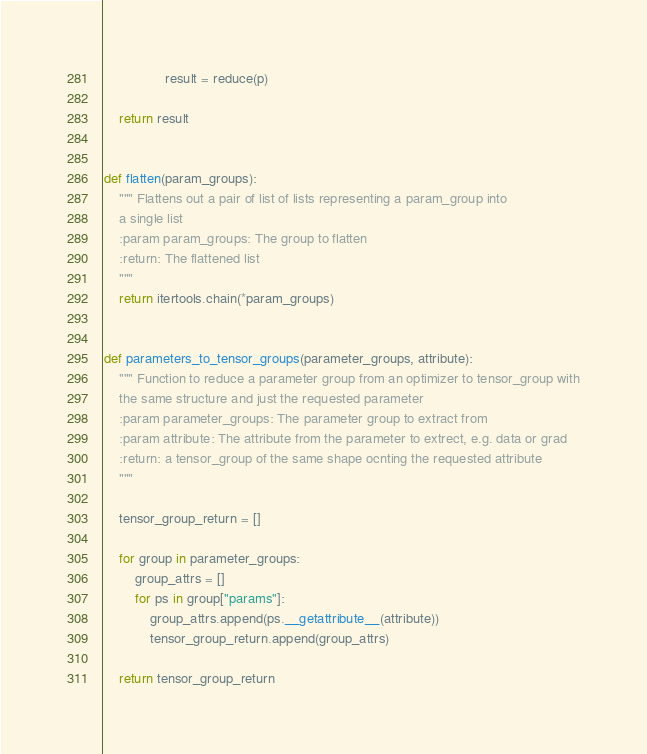<code> <loc_0><loc_0><loc_500><loc_500><_Python_>                result = reduce(p)

    return result


def flatten(param_groups):
    """ Flattens out a pair of list of lists representing a param_group into
    a single list
    :param param_groups: The group to flatten
    :return: The flattened list
    """
    return itertools.chain(*param_groups)


def parameters_to_tensor_groups(parameter_groups, attribute):
    """ Function to reduce a parameter group from an optimizer to tensor_group with
    the same structure and just the requested parameter
    :param parameter_groups: The parameter group to extract from
    :param attribute: The attribute from the parameter to extrect, e.g. data or grad
    :return: a tensor_group of the same shape ocnting the requested attribute
    """

    tensor_group_return = []

    for group in parameter_groups:
        group_attrs = []
        for ps in group["params"]:
            group_attrs.append(ps.__getattribute__(attribute))
            tensor_group_return.append(group_attrs)

    return tensor_group_return</code> 